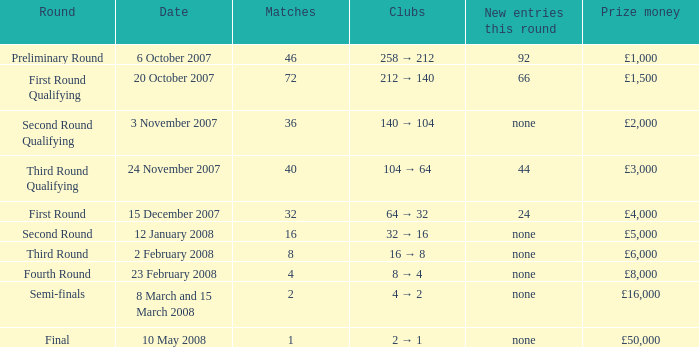What are the organizations with 46 matches? 258 → 212. 